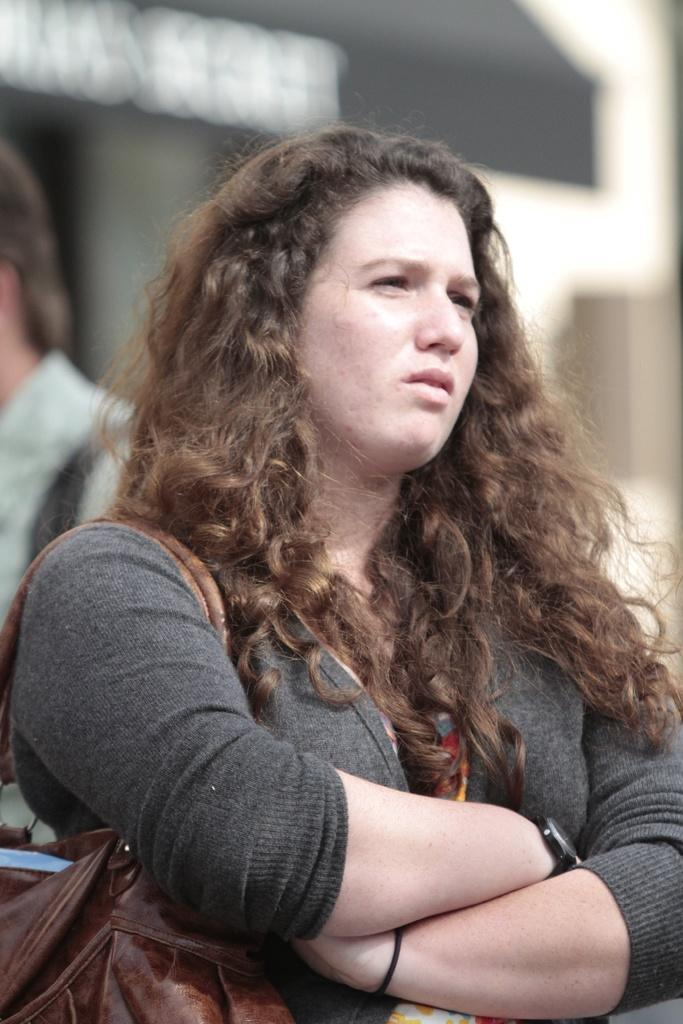How many people are in the image? There are two persons in the image. What are the persons wearing? The persons are wearing bags. Can you describe the background of the image? The background of the image is blurred. What type of meal is being prepared by the persons in the image? There is no indication of a meal or any food preparation in the image. 